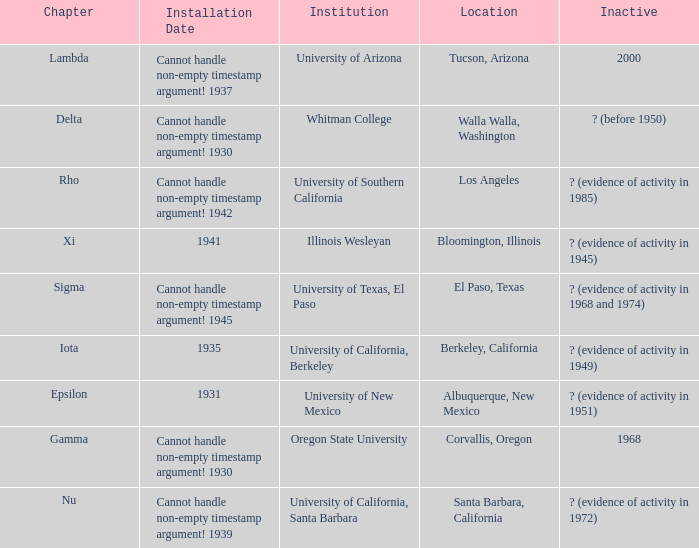What is the assigned chapter for illinois wesleyan? Xi. 